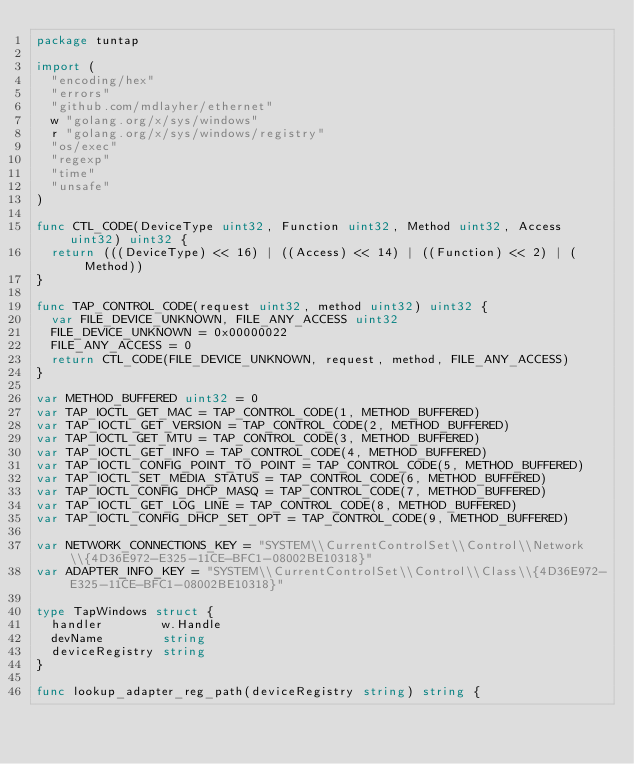<code> <loc_0><loc_0><loc_500><loc_500><_Go_>package tuntap

import (
	"encoding/hex"
	"errors"
	"github.com/mdlayher/ethernet"
	w "golang.org/x/sys/windows"
	r "golang.org/x/sys/windows/registry"
	"os/exec"
	"regexp"
	"time"
	"unsafe"
)

func CTL_CODE(DeviceType uint32, Function uint32, Method uint32, Access uint32) uint32 {
	return (((DeviceType) << 16) | ((Access) << 14) | ((Function) << 2) | (Method))
}

func TAP_CONTROL_CODE(request uint32, method uint32) uint32 {
	var FILE_DEVICE_UNKNOWN, FILE_ANY_ACCESS uint32
	FILE_DEVICE_UNKNOWN = 0x00000022
	FILE_ANY_ACCESS = 0
	return CTL_CODE(FILE_DEVICE_UNKNOWN, request, method, FILE_ANY_ACCESS)
}

var METHOD_BUFFERED uint32 = 0
var TAP_IOCTL_GET_MAC = TAP_CONTROL_CODE(1, METHOD_BUFFERED)
var TAP_IOCTL_GET_VERSION = TAP_CONTROL_CODE(2, METHOD_BUFFERED)
var TAP_IOCTL_GET_MTU = TAP_CONTROL_CODE(3, METHOD_BUFFERED)
var TAP_IOCTL_GET_INFO = TAP_CONTROL_CODE(4, METHOD_BUFFERED)
var TAP_IOCTL_CONFIG_POINT_TO_POINT = TAP_CONTROL_CODE(5, METHOD_BUFFERED)
var TAP_IOCTL_SET_MEDIA_STATUS = TAP_CONTROL_CODE(6, METHOD_BUFFERED)
var TAP_IOCTL_CONFIG_DHCP_MASQ = TAP_CONTROL_CODE(7, METHOD_BUFFERED)
var TAP_IOCTL_GET_LOG_LINE = TAP_CONTROL_CODE(8, METHOD_BUFFERED)
var TAP_IOCTL_CONFIG_DHCP_SET_OPT = TAP_CONTROL_CODE(9, METHOD_BUFFERED)

var NETWORK_CONNECTIONS_KEY = "SYSTEM\\CurrentControlSet\\Control\\Network\\{4D36E972-E325-11CE-BFC1-08002BE10318}"
var ADAPTER_INFO_KEY = "SYSTEM\\CurrentControlSet\\Control\\Class\\{4D36E972-E325-11CE-BFC1-08002BE10318}"

type TapWindows struct {
	handler        w.Handle
	devName        string
	deviceRegistry string
}

func lookup_adapter_reg_path(deviceRegistry string) string {</code> 